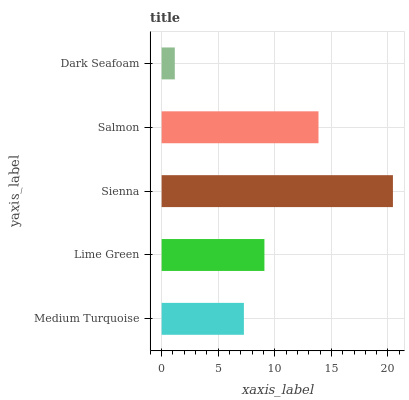Is Dark Seafoam the minimum?
Answer yes or no. Yes. Is Sienna the maximum?
Answer yes or no. Yes. Is Lime Green the minimum?
Answer yes or no. No. Is Lime Green the maximum?
Answer yes or no. No. Is Lime Green greater than Medium Turquoise?
Answer yes or no. Yes. Is Medium Turquoise less than Lime Green?
Answer yes or no. Yes. Is Medium Turquoise greater than Lime Green?
Answer yes or no. No. Is Lime Green less than Medium Turquoise?
Answer yes or no. No. Is Lime Green the high median?
Answer yes or no. Yes. Is Lime Green the low median?
Answer yes or no. Yes. Is Salmon the high median?
Answer yes or no. No. Is Medium Turquoise the low median?
Answer yes or no. No. 